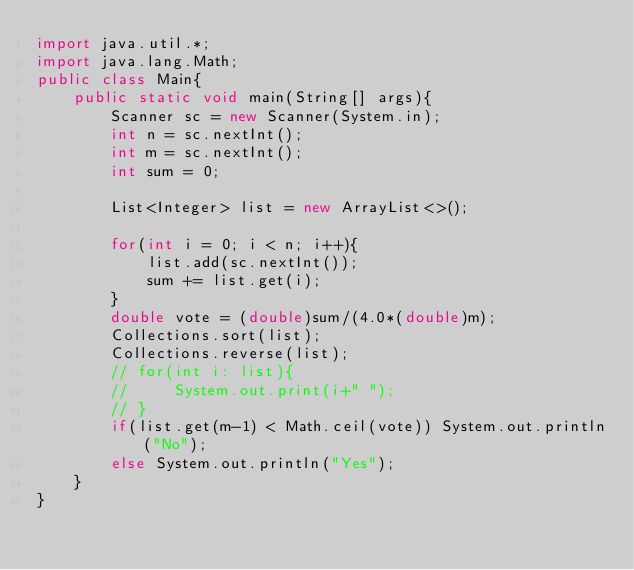Convert code to text. <code><loc_0><loc_0><loc_500><loc_500><_Java_>import java.util.*;
import java.lang.Math;
public class Main{
    public static void main(String[] args){
        Scanner sc = new Scanner(System.in);
        int n = sc.nextInt();
        int m = sc.nextInt();
        int sum = 0;

        List<Integer> list = new ArrayList<>();

        for(int i = 0; i < n; i++){
            list.add(sc.nextInt());
            sum += list.get(i);
        }
        double vote = (double)sum/(4.0*(double)m);
        Collections.sort(list);
        Collections.reverse(list);
        // for(int i: list){
        //     System.out.print(i+" ");
        // }
        if(list.get(m-1) < Math.ceil(vote)) System.out.println("No");
        else System.out.println("Yes");
    }
}</code> 